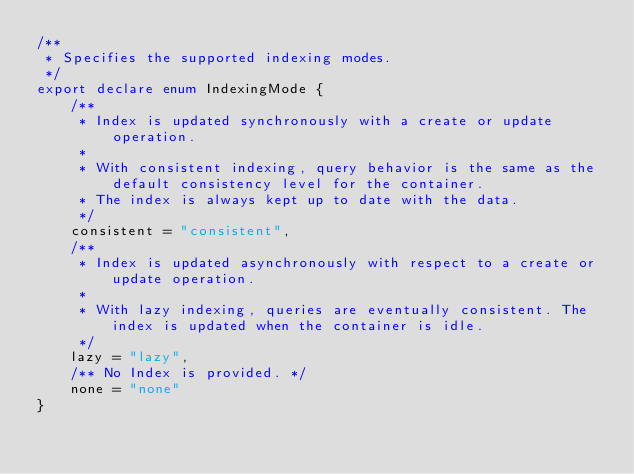Convert code to text. <code><loc_0><loc_0><loc_500><loc_500><_TypeScript_>/**
 * Specifies the supported indexing modes.
 */
export declare enum IndexingMode {
    /**
     * Index is updated synchronously with a create or update operation.
     *
     * With consistent indexing, query behavior is the same as the default consistency level for the container.
     * The index is always kept up to date with the data.
     */
    consistent = "consistent",
    /**
     * Index is updated asynchronously with respect to a create or update operation.
     *
     * With lazy indexing, queries are eventually consistent. The index is updated when the container is idle.
     */
    lazy = "lazy",
    /** No Index is provided. */
    none = "none"
}</code> 